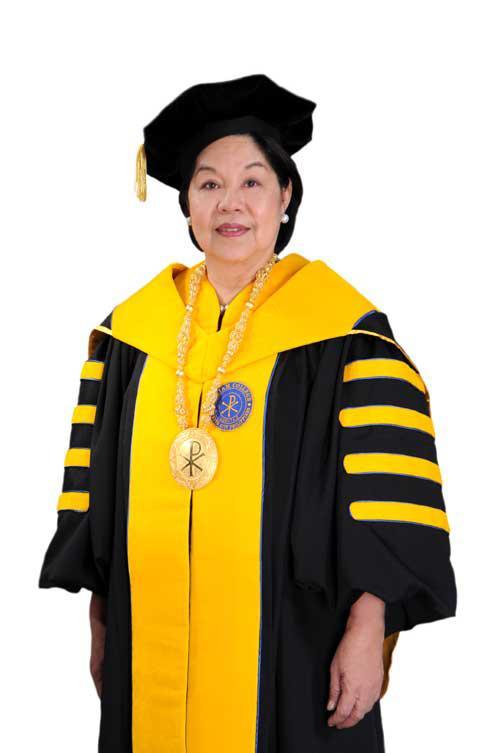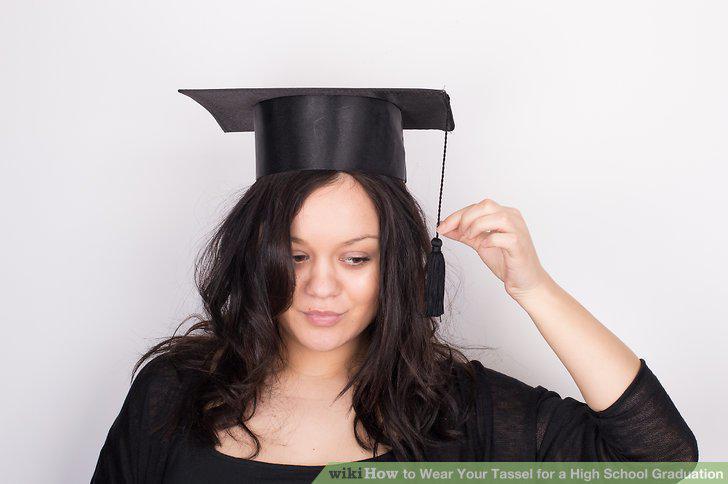The first image is the image on the left, the second image is the image on the right. Given the left and right images, does the statement "One image shows a brunette female grasping the black tassel on her graduation cap." hold true? Answer yes or no. Yes. The first image is the image on the left, the second image is the image on the right. Analyze the images presented: Is the assertion "A mona is holding the tassel on her mortarboard." valid? Answer yes or no. Yes. 